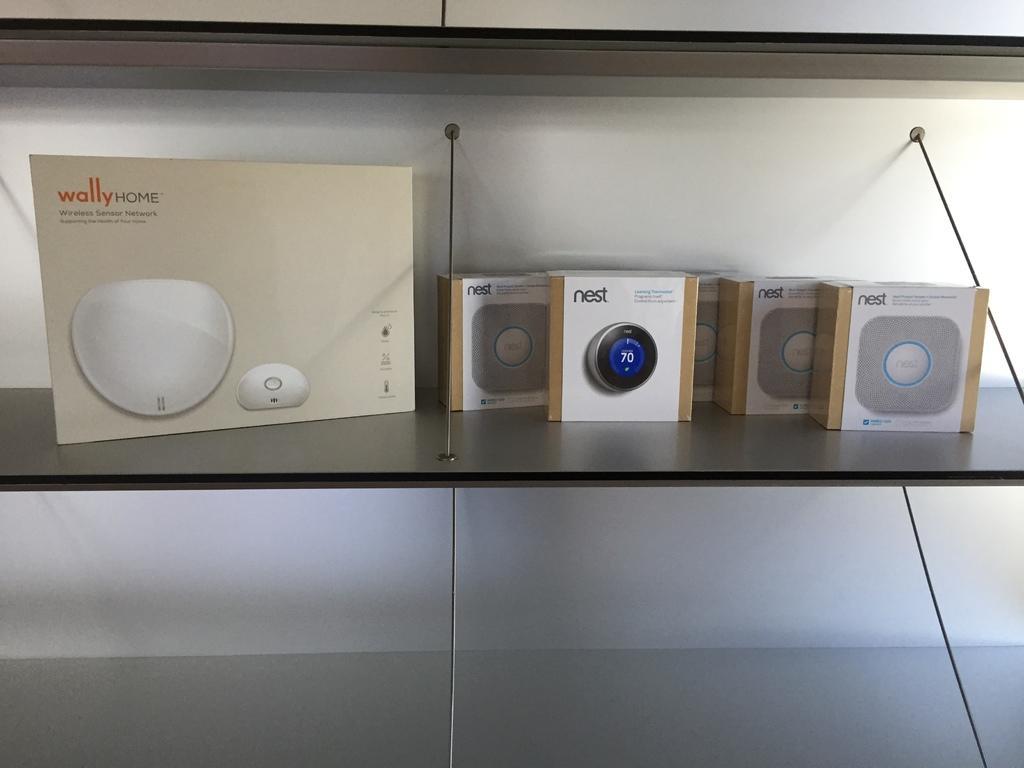Can you describe this image briefly? In this picture I can see few boxes on the shelf and I can see a wall in the background. 